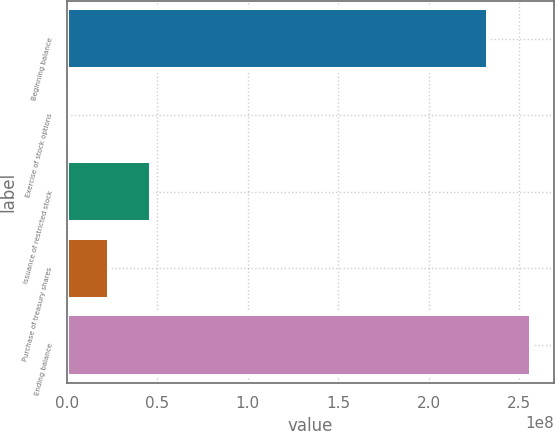Convert chart. <chart><loc_0><loc_0><loc_500><loc_500><bar_chart><fcel>Beginning balance<fcel>Exercise of stock options<fcel>Issuance of restricted stock<fcel>Purchase of treasury shares<fcel>Ending balance<nl><fcel>2.33082e+08<fcel>17600<fcel>4.66369e+07<fcel>2.33273e+07<fcel>2.56391e+08<nl></chart> 